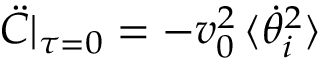<formula> <loc_0><loc_0><loc_500><loc_500>\ddot { C } | _ { \tau = 0 } = - v _ { 0 } ^ { 2 } \, \langle \dot { \theta } _ { i } ^ { 2 } \rangle</formula> 